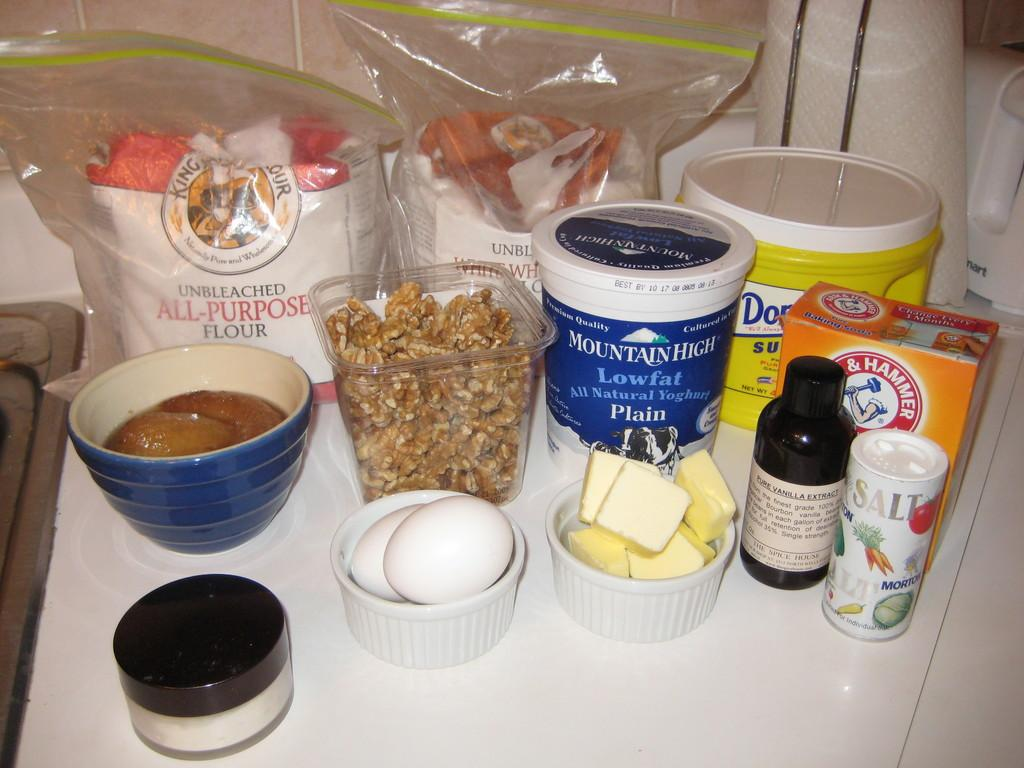<image>
Share a concise interpretation of the image provided. a table has lots of ingredients including low fat yoghurt 